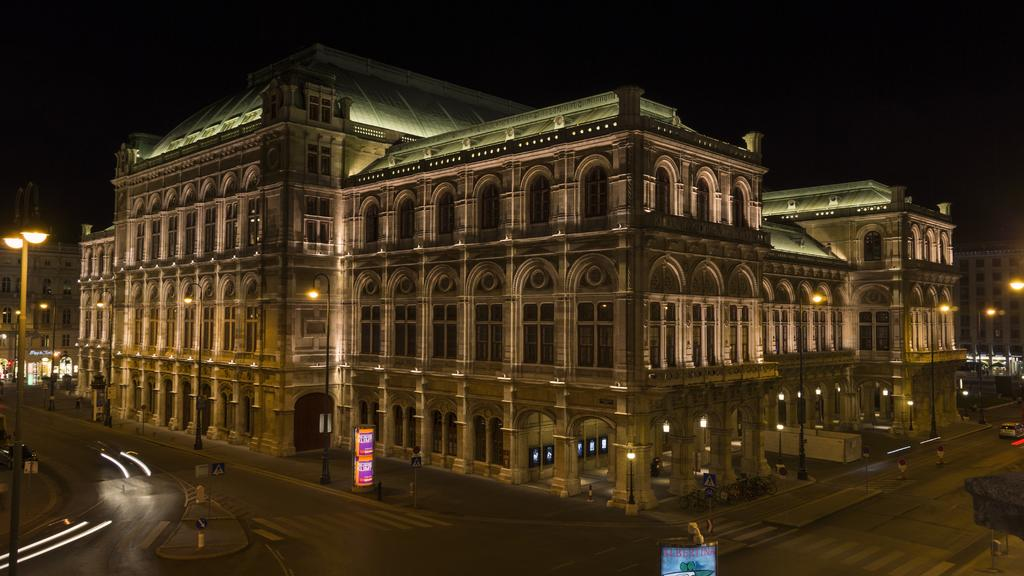What is the main structure in the center of the image? There is a building in the center of the image. What are the tall, thin structures in the image? There are poles in the image. What are the tall, thin structures with lights on top in the image? There are street lights in the image. What are the flat, rectangular objects in the image? There are boards in the image. What are the various objects in the image? There are objects in the image, including the building, poles, street lights, and boards. What is the pathway at the bottom of the image used for? There is a walkway at the bottom of the image, which is likely used for walking or moving around. What is visible at the top of the image? The sky is visible at the top of the image. What question is being asked in the image? There is no question being asked in the image; it is a visual representation of various structures and objects. 